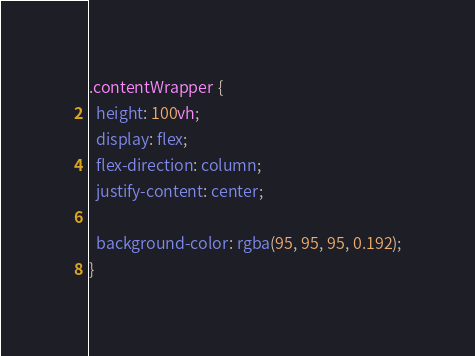<code> <loc_0><loc_0><loc_500><loc_500><_CSS_>.contentWrapper {
  height: 100vh;
  display: flex;
  flex-direction: column;
  justify-content: center;

  background-color: rgba(95, 95, 95, 0.192);
}
</code> 